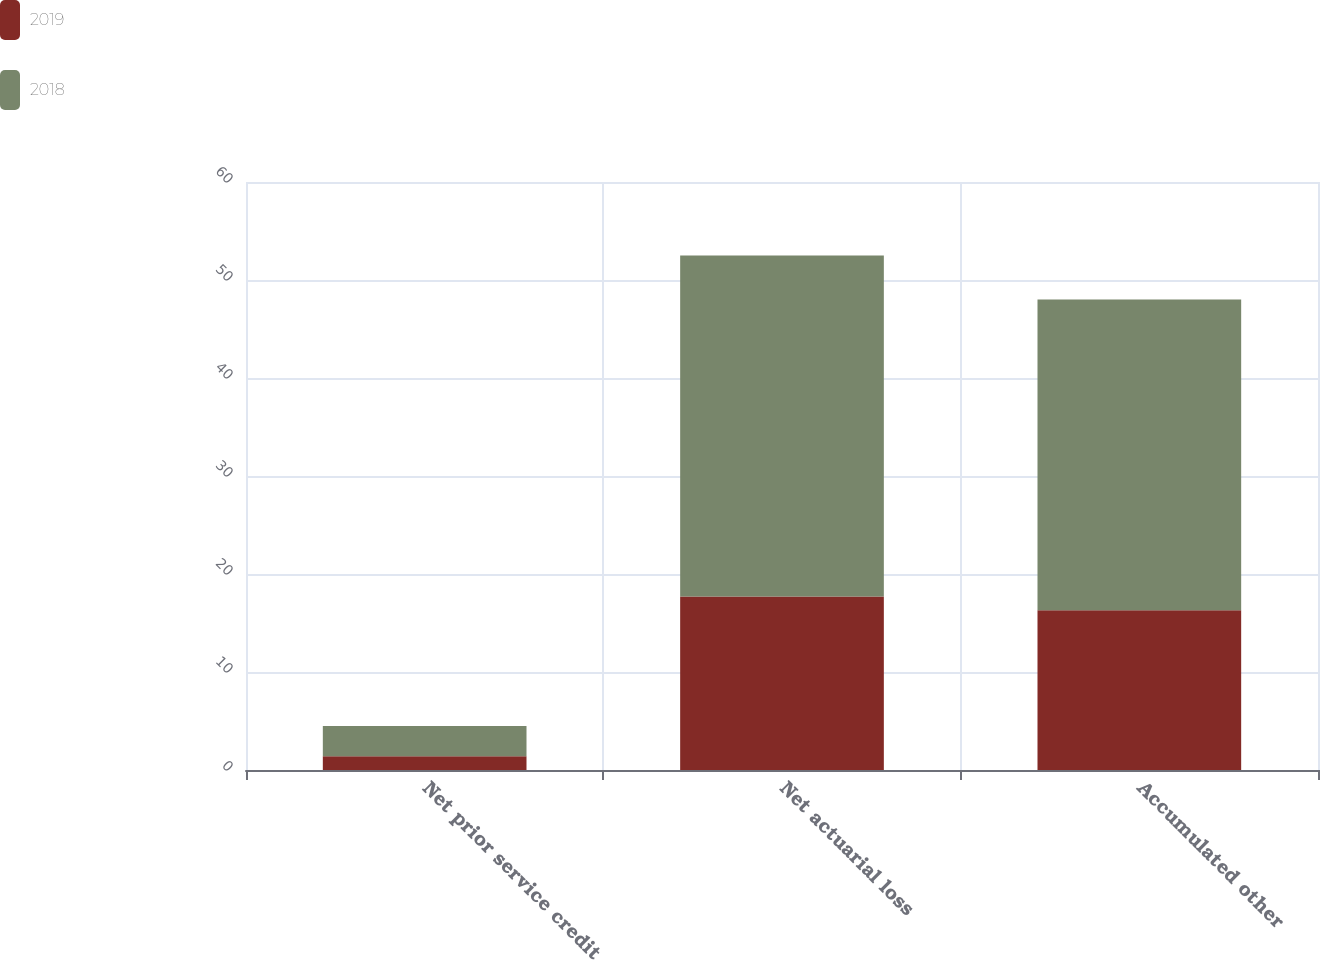Convert chart to OTSL. <chart><loc_0><loc_0><loc_500><loc_500><stacked_bar_chart><ecel><fcel>Net prior service credit<fcel>Net actuarial loss<fcel>Accumulated other<nl><fcel>2019<fcel>1.4<fcel>17.7<fcel>16.3<nl><fcel>2018<fcel>3.1<fcel>34.8<fcel>31.7<nl></chart> 